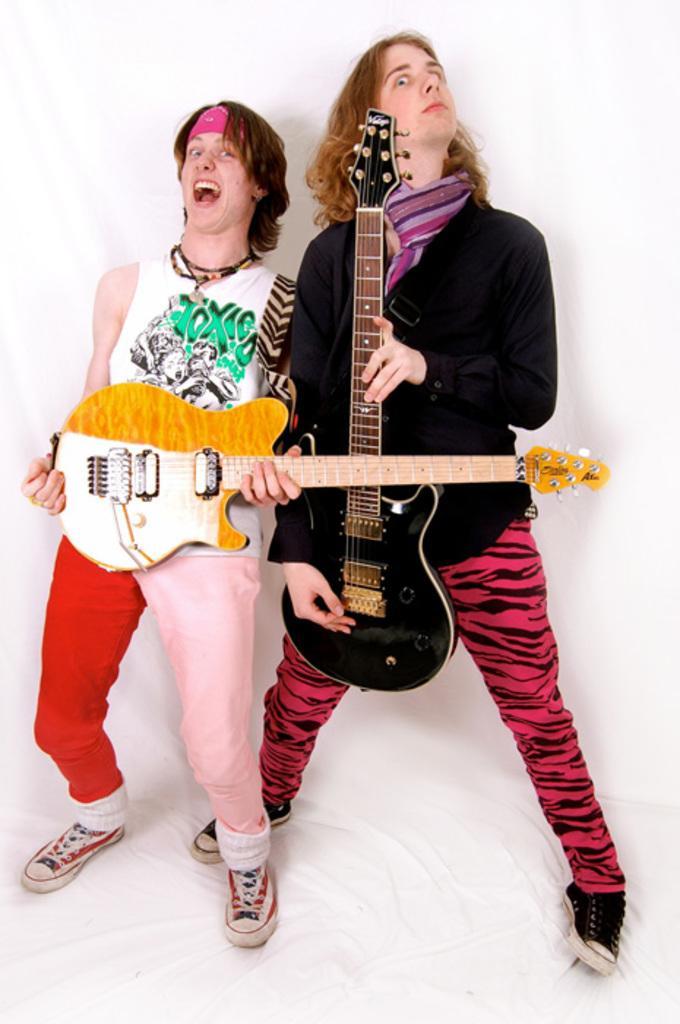Can you describe this image briefly? There are 2 men holding guitar in their hands individually. 